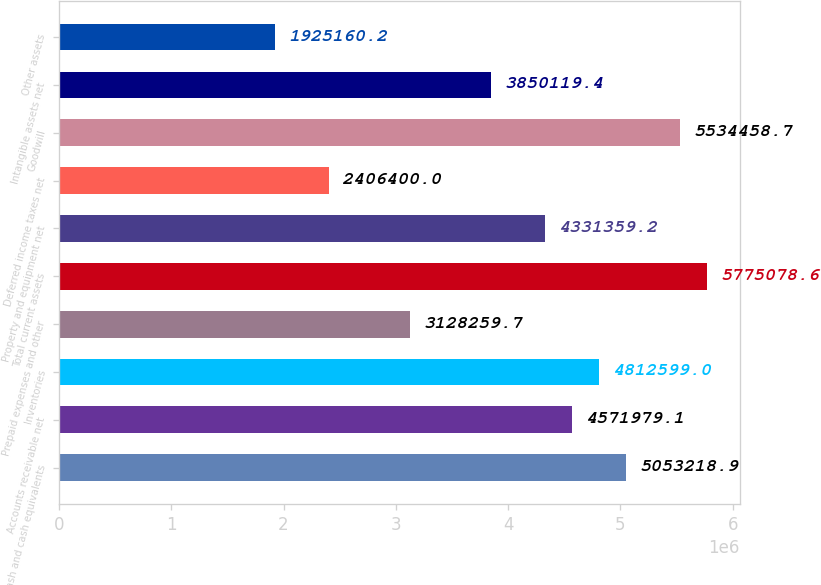Convert chart to OTSL. <chart><loc_0><loc_0><loc_500><loc_500><bar_chart><fcel>Cash and cash equivalents<fcel>Accounts receivable net<fcel>Inventories<fcel>Prepaid expenses and other<fcel>Total current assets<fcel>Property and equipment net<fcel>Deferred income taxes net<fcel>Goodwill<fcel>Intangible assets net<fcel>Other assets<nl><fcel>5.05322e+06<fcel>4.57198e+06<fcel>4.8126e+06<fcel>3.12826e+06<fcel>5.77508e+06<fcel>4.33136e+06<fcel>2.4064e+06<fcel>5.53446e+06<fcel>3.85012e+06<fcel>1.92516e+06<nl></chart> 